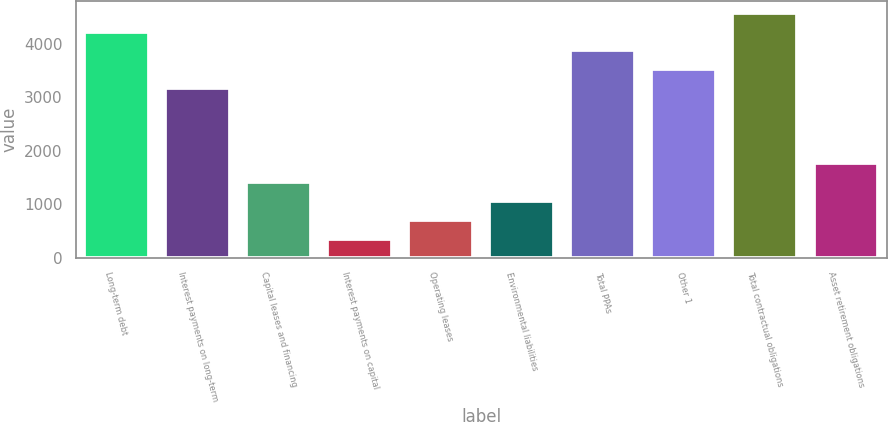Convert chart. <chart><loc_0><loc_0><loc_500><loc_500><bar_chart><fcel>Long-term debt<fcel>Interest payments on long-term<fcel>Capital leases and financing<fcel>Interest payments on capital<fcel>Operating leases<fcel>Environmental liabilities<fcel>Total PPAs<fcel>Other 1<fcel>Total contractual obligations<fcel>Asset retirement obligations<nl><fcel>4226.8<fcel>3171.1<fcel>1411.6<fcel>355.9<fcel>707.8<fcel>1059.7<fcel>3874.9<fcel>3523<fcel>4578.7<fcel>1763.5<nl></chart> 